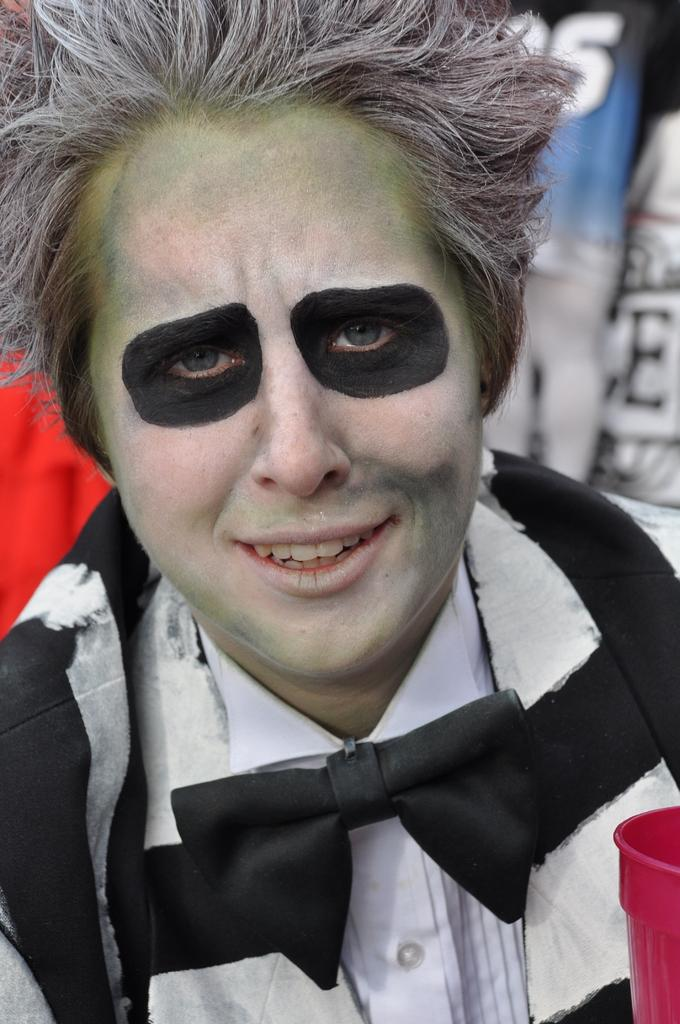What is the main subject of the image? There is a person in the image. Can you describe the appearance of the person? The person has makeup on their face. What type of feather can be seen on the person's dad in the image? There is no dad or feather present in the image; it only features a person with makeup on their face. 